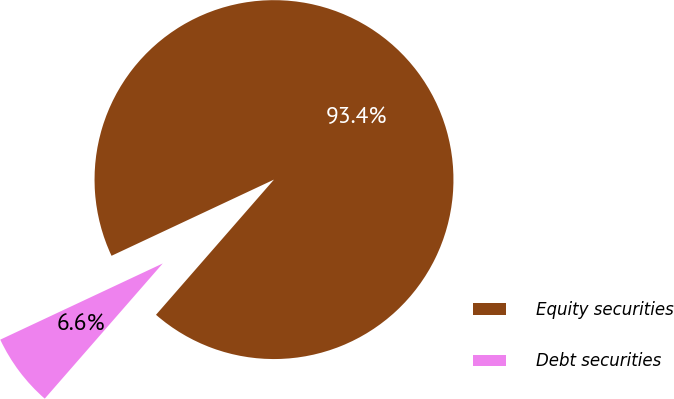Convert chart to OTSL. <chart><loc_0><loc_0><loc_500><loc_500><pie_chart><fcel>Equity securities<fcel>Debt securities<nl><fcel>93.4%<fcel>6.6%<nl></chart> 